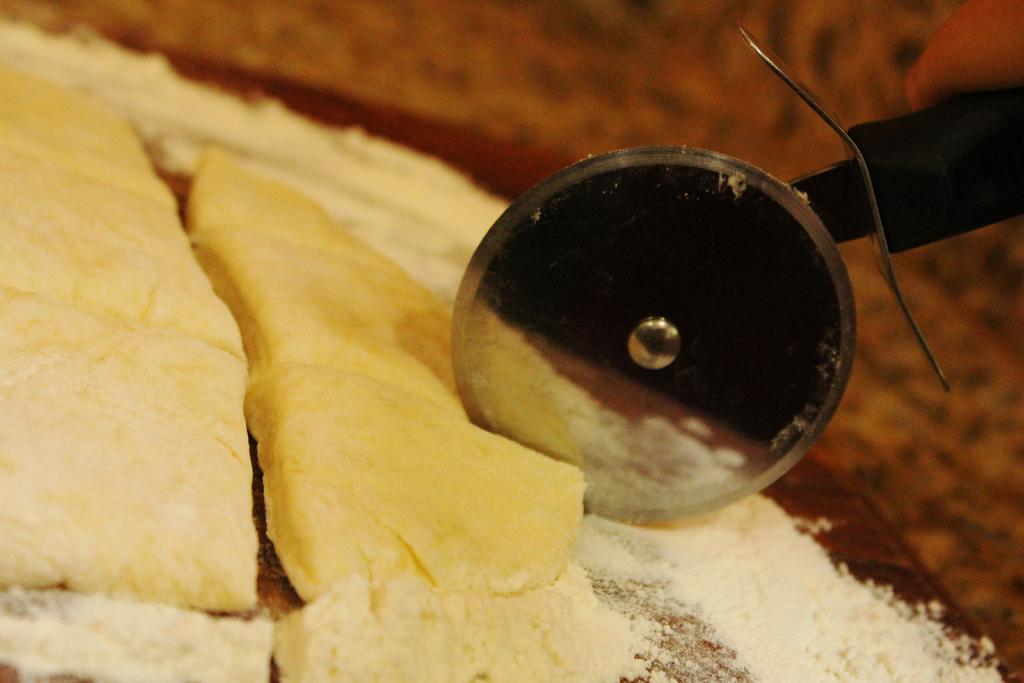What object is visible in the image that is used for cutting food? There is a pizza cutter in the image. What is the primary location of the food in the image? The food is placed on a table in the image. What is the color of the food in the image? The food is yellow in color. Can you describe the background of the image? The background of the image is blurred. What type of jelly is being sorted at the event in the image? There is no jelly or event present in the image; it features a pizza cutter and yellow food on a table. 